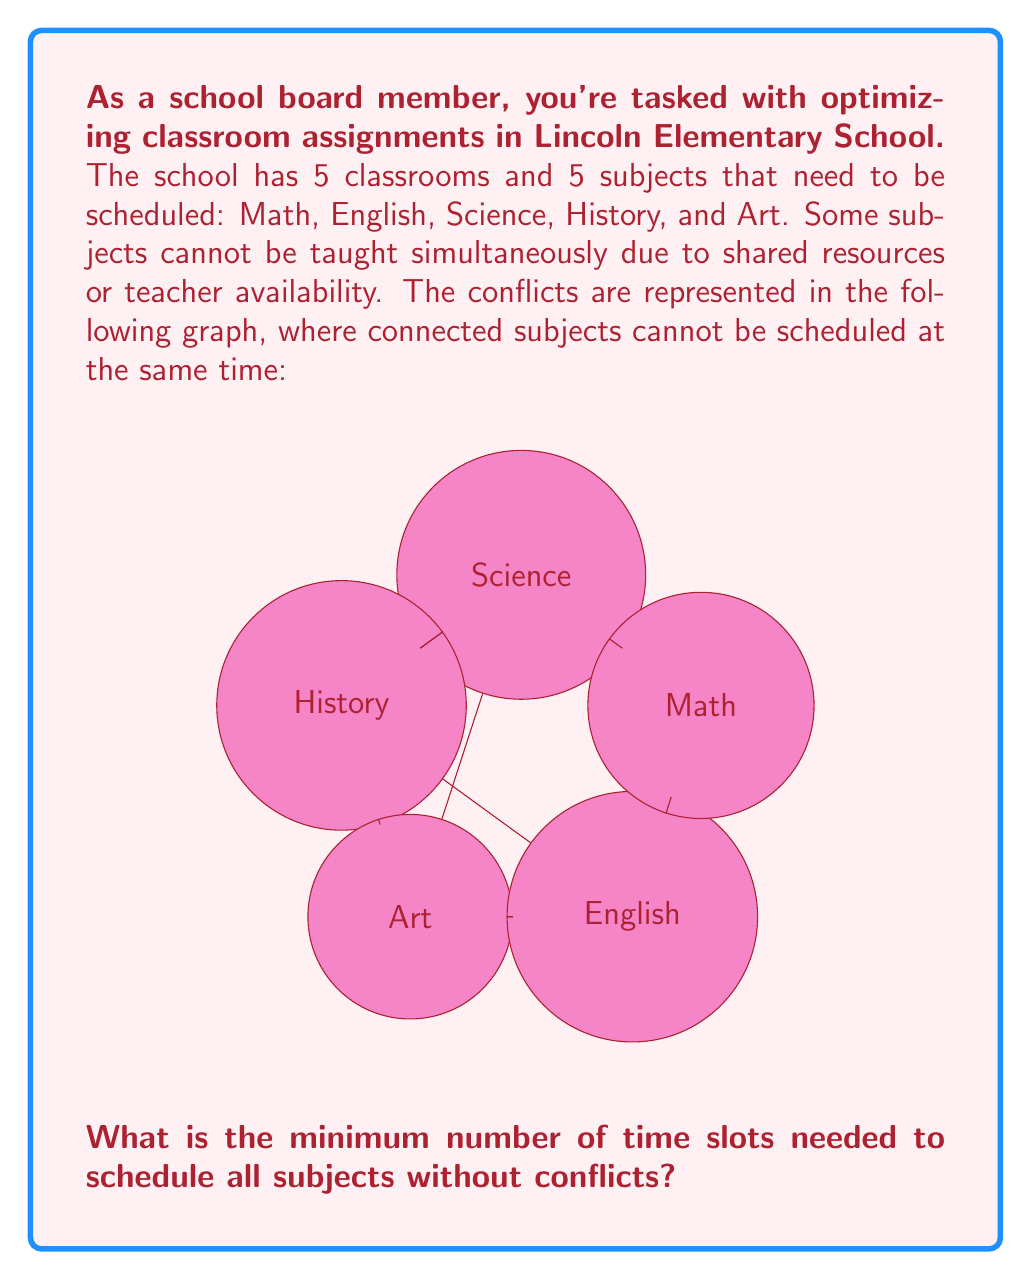Give your solution to this math problem. To solve this problem, we can use graph coloring techniques. Each color represents a time slot, and connected vertices (subjects) must have different colors.

Step 1: Analyze the graph
- The graph is not complete (not all vertices are connected).
- The maximum degree (number of connections) of any vertex is 3.

Step 2: Apply the graph coloring algorithm
We can use a greedy coloring algorithm:
1. Start with Math (any vertex can be first).
2. Assign the first available color to each vertex, ensuring no adjacent vertices have the same color.

Color assignment:
- Math: Color 1
- English: Color 2 (connected to Math)
- Science: Color 3 (connected to Math and English)
- History: Color 2 (connected to Math and Science, but not English)
- Art: Color 1 (connected to English, but not Math)

Step 3: Count the number of colors used
We used 3 colors in total, which represents the minimum number of time slots needed.

This solution is optimal because:
1. It satisfies all constraints (no conflicting subjects in the same time slot).
2. The number of colors used (3) is equal to the chromatic number of this graph, which is at most the maximum degree + 1 (3 + 1 = 4 in this case).

Therefore, 3 is the minimum number of time slots needed to schedule all subjects without conflicts.
Answer: 3 time slots 